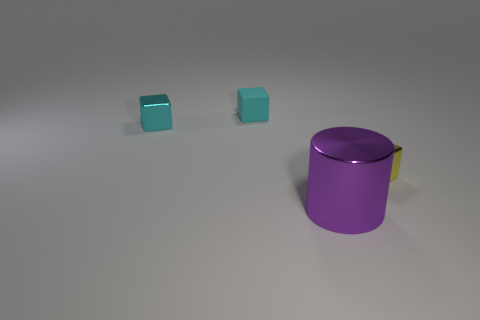There is a metallic block on the left side of the cyan matte cube; does it have the same color as the rubber cube?
Give a very brief answer. Yes. The other cyan object that is the same shape as the tiny cyan shiny thing is what size?
Your answer should be very brief. Small. What number of objects are either tiny cubes that are left of the large purple object or tiny objects that are in front of the small cyan metal cube?
Make the answer very short. 3. There is a metal object in front of the shiny block to the right of the big shiny cylinder; what shape is it?
Offer a terse response. Cylinder. Is there any other thing of the same color as the matte cube?
Your answer should be compact. Yes. Is there anything else that is the same size as the purple thing?
Your answer should be compact. No. What number of things are either small green things or large purple metal things?
Offer a terse response. 1. Is there a red cube of the same size as the cyan metallic cube?
Your answer should be very brief. No. What shape is the yellow object?
Offer a very short reply. Cube. Is the number of small metal blocks left of the yellow cube greater than the number of cylinders to the left of the large metallic cylinder?
Ensure brevity in your answer.  Yes. 